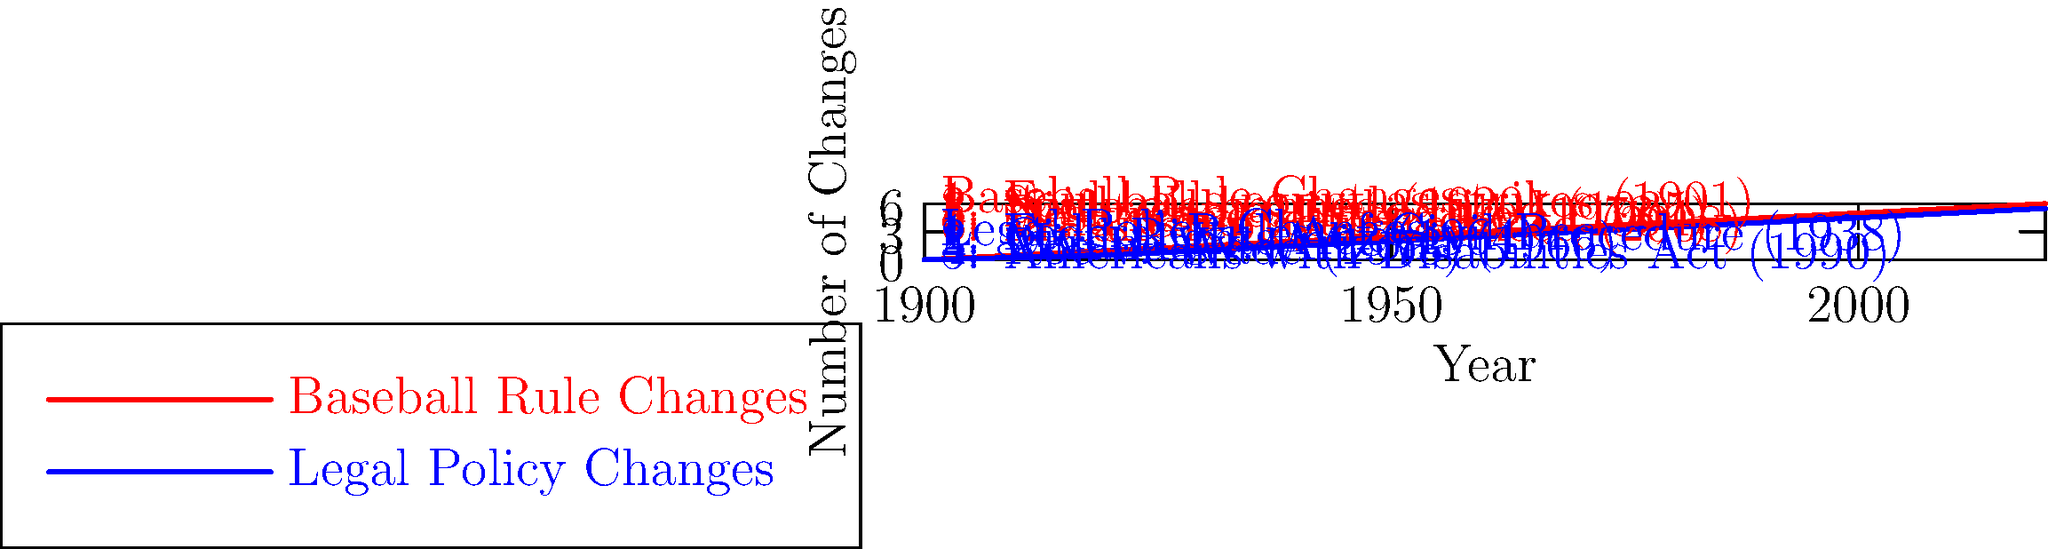Analyze the parallel timelines of baseball rule changes and legal policy changes. Which decade saw the most significant correlation between changes in both fields, and what might explain this relationship? To answer this question, we need to examine the timelines closely and identify periods where both baseball and legal changes occurred in close proximity. Let's break it down by decade:

1. 1900-1920: Baseball saw the foul ball strike rule (1901) and spitball ban (1920). No major legal changes noted.

2. 1920-1940: Baseball introduced night games (1935). Legal field saw the Federal Rules of Civil Procedure (1938).

3. 1940-1960: No significant changes noted in either field during this period.

4. 1960-1980: This decade shows the most correlation:
   - Baseball: Designated Hitter rule (1973)
   - Legal: Civil Rights Act (1964), Miranda v. Arizona (1966), Roe v. Wade (1973)

5. 1980-2000: Baseball added Wild Card teams (1994). Legal field saw the Americans with Disabilities Act (1990).

6. 2000-2020: Baseball introduced instant replay (2008). No major legal changes noted.

The 1960s-1970s decade shows the most significant correlation. This can be explained by the broader social and cultural changes occurring in the United States during this period. The Civil Rights Movement, women's rights movement, and overall push for equality and fairness in society likely influenced both legal policies and sports rules. 

The Designated Hitter rule in baseball aimed to increase offensive production and fan interest, which aligns with the era's focus on individual rights and opportunities. Similarly, legal changes like the Civil Rights Act, Miranda rights, and Roe v. Wade decision expanded individual protections and rights under the law.

Both fields were responding to societal demands for fairness, equality, and modernization, leading to significant changes occurring in parallel during this transformative period in American history.
Answer: 1960s-1970s, due to parallel societal changes demanding fairness and equality in both fields. 